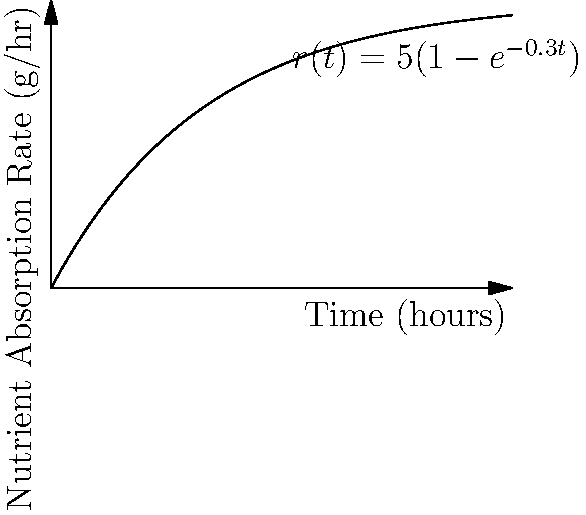The graph shows the rate of nutrient absorption $r(t)$ in grams per hour as a function of time $t$ in hours after ingestion. The function is given by $r(t) = 5(1-e^{-0.3t})$. At what time is the rate of change of nutrient absorption exactly 1 g/hr²? To solve this problem, we need to follow these steps:

1) The rate of change of nutrient absorption is the derivative of $r(t)$ with respect to $t$. Let's call this $r'(t)$.

2) We need to find $r'(t)$:
   $r'(t) = \frac{d}{dt}[5(1-e^{-0.3t})]$
   $r'(t) = 5 \cdot \frac{d}{dt}[1-e^{-0.3t}]$
   $r'(t) = 5 \cdot (0 + 0.3e^{-0.3t})$
   $r'(t) = 1.5e^{-0.3t}$

3) We want to find $t$ when $r'(t) = 1$:
   $1.5e^{-0.3t} = 1$

4) Solving this equation:
   $e^{-0.3t} = \frac{2}{3}$
   $-0.3t = \ln(\frac{2}{3})$
   $t = -\frac{1}{0.3} \ln(\frac{2}{3})$

5) Calculating this value:
   $t \approx 1.3541$ hours

Therefore, the rate of change of nutrient absorption is exactly 1 g/hr² after approximately 1.3541 hours.
Answer: $-\frac{1}{0.3} \ln(\frac{2}{3}) \approx 1.3541$ hours 